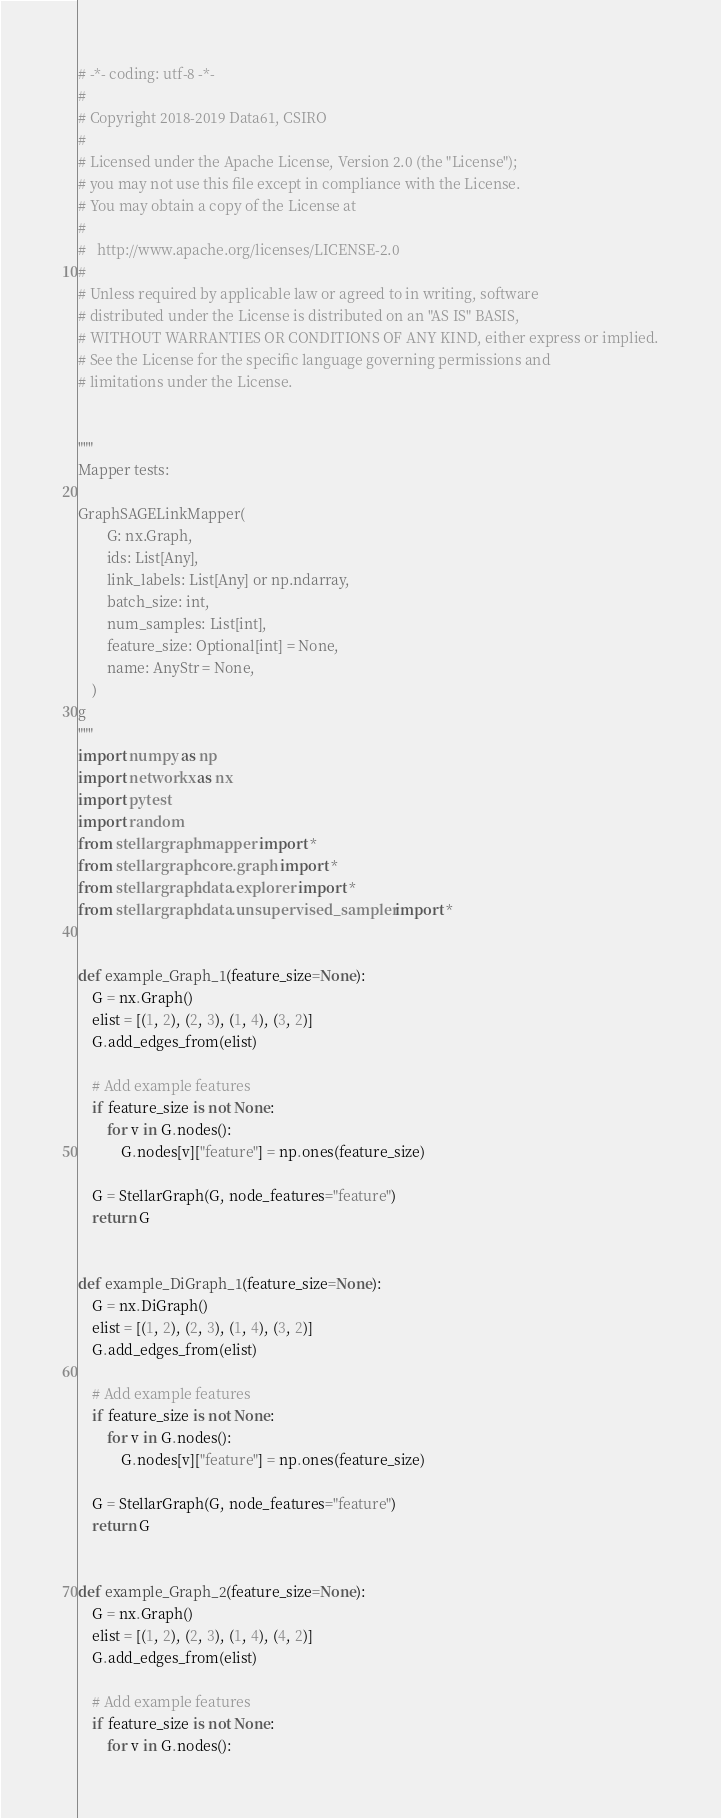<code> <loc_0><loc_0><loc_500><loc_500><_Python_># -*- coding: utf-8 -*-
#
# Copyright 2018-2019 Data61, CSIRO
#
# Licensed under the Apache License, Version 2.0 (the "License");
# you may not use this file except in compliance with the License.
# You may obtain a copy of the License at
#
#   http://www.apache.org/licenses/LICENSE-2.0
#
# Unless required by applicable law or agreed to in writing, software
# distributed under the License is distributed on an "AS IS" BASIS,
# WITHOUT WARRANTIES OR CONDITIONS OF ANY KIND, either express or implied.
# See the License for the specific language governing permissions and
# limitations under the License.


"""
Mapper tests:

GraphSAGELinkMapper(
        G: nx.Graph,
        ids: List[Any],
        link_labels: List[Any] or np.ndarray,
        batch_size: int,
        num_samples: List[int],
        feature_size: Optional[int] = None,
        name: AnyStr = None,
    )
g
"""
import numpy as np
import networkx as nx
import pytest
import random
from stellargraph.mapper import *
from stellargraph.core.graph import *
from stellargraph.data.explorer import *
from stellargraph.data.unsupervised_sampler import *


def example_Graph_1(feature_size=None):
    G = nx.Graph()
    elist = [(1, 2), (2, 3), (1, 4), (3, 2)]
    G.add_edges_from(elist)

    # Add example features
    if feature_size is not None:
        for v in G.nodes():
            G.nodes[v]["feature"] = np.ones(feature_size)

    G = StellarGraph(G, node_features="feature")
    return G


def example_DiGraph_1(feature_size=None):
    G = nx.DiGraph()
    elist = [(1, 2), (2, 3), (1, 4), (3, 2)]
    G.add_edges_from(elist)

    # Add example features
    if feature_size is not None:
        for v in G.nodes():
            G.nodes[v]["feature"] = np.ones(feature_size)

    G = StellarGraph(G, node_features="feature")
    return G


def example_Graph_2(feature_size=None):
    G = nx.Graph()
    elist = [(1, 2), (2, 3), (1, 4), (4, 2)]
    G.add_edges_from(elist)

    # Add example features
    if feature_size is not None:
        for v in G.nodes():</code> 